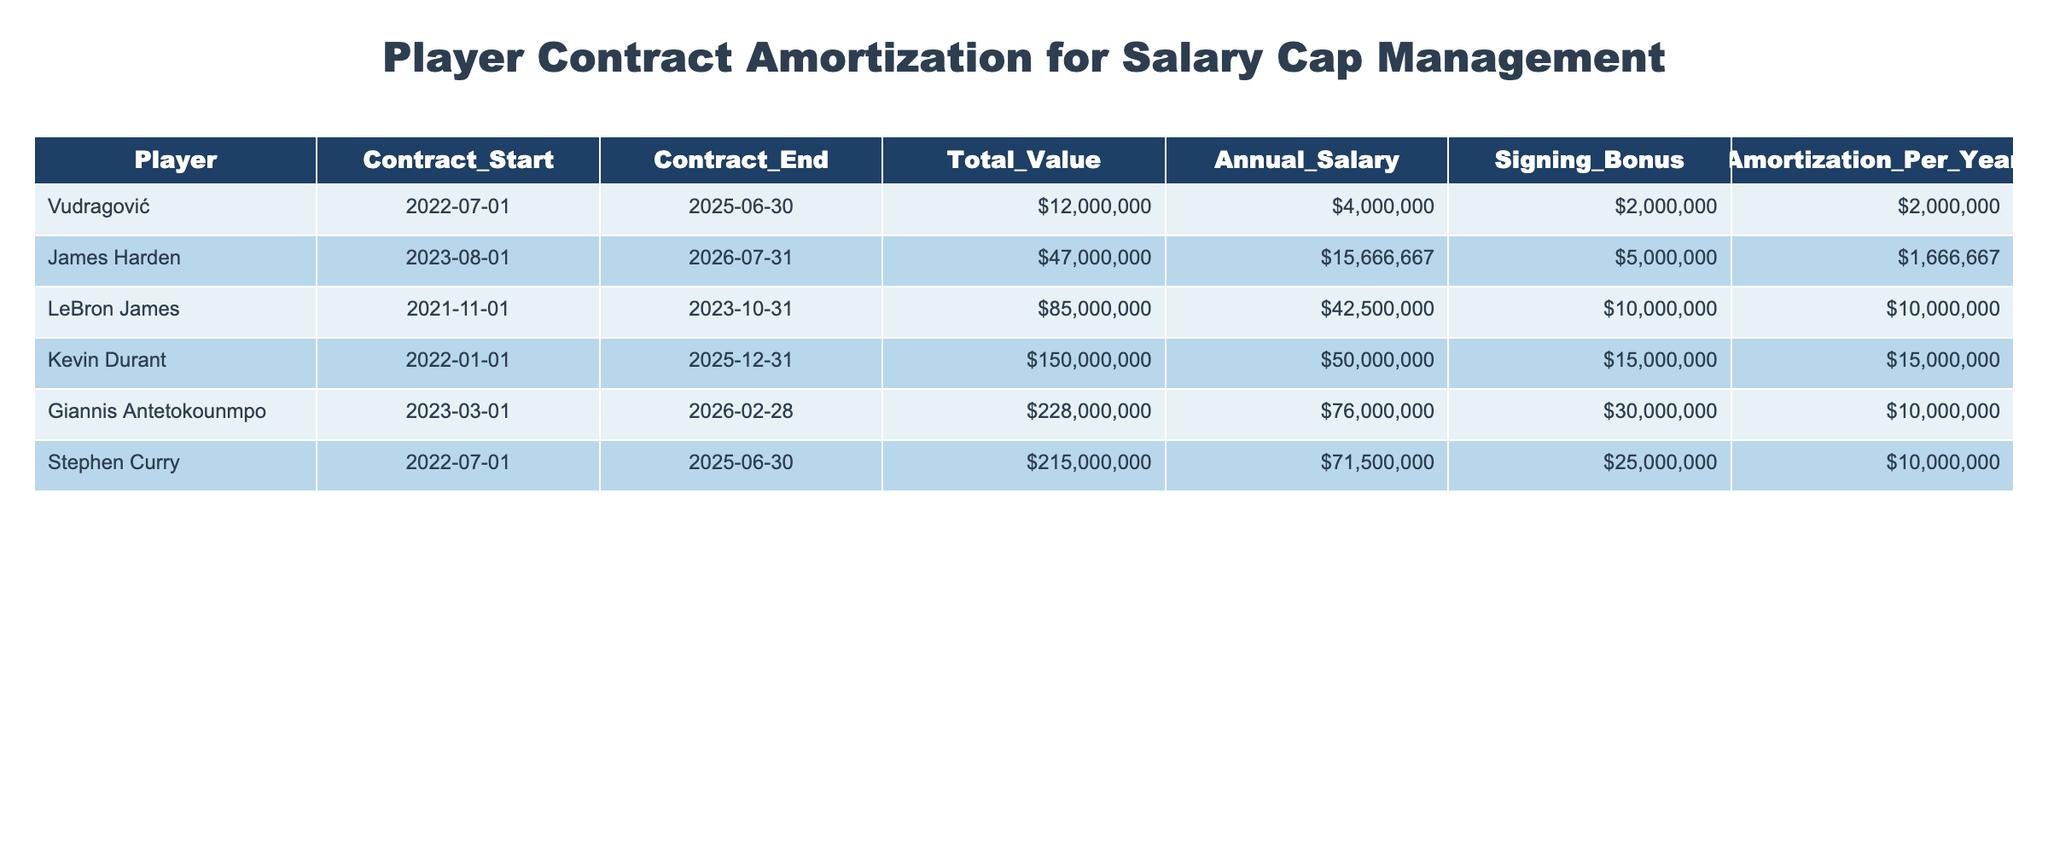What is the total contract value for Vudragović? The total contract value for Vudragović is listed directly in the table under the "Total_Value" column. Referring to that row, the value is $12,000,000.
Answer: $12,000,000 Who has the highest annual salary in the table? To determine who has the highest annual salary, I need to compare the values in the "Annual_Salary" column. LeBron James has the highest annual salary of $42,500,000.
Answer: LeBron James What is the signing bonus for Kevin Durant? The signing bonus for Kevin Durant can be found in the "Signing_Bonus" column in his respective row. The value is $15,000,000.
Answer: $15,000,000 Is Giannis Antetokounmpo's signing bonus greater than Vudragović's? I will compare the signing bonuses in the respective rows: Giannis Antetokounmpo has a signing bonus of $30,000,000 while Vudragović has $2,000,000. Since $30,000,000 is greater than $2,000,000, the answer is yes.
Answer: Yes What is the total amortization per year for all players combined? To find the total amortization per year, I will sum the "Amortization_Per_Year" values for each player. This calculates to $2,000,000 + $1,666,667 + $10,000,000 + $15,000,000 + $10,000,000 + $10,000,000 = $48,666,667.
Answer: $48,666,667 What is the average annual salary of the players in the table? I will sum the values in the "Annual_Salary" column, which gives: $4,000,000 + $15,666,667 + $42,500,000 + $50,000,000 + $76,000,000 + $71,500,000 = $259,666,667. There are 6 players, so the average is $259,666,667 divided by 6, which equals $43,277,778.
Answer: $43,277,778 Does Stephen Curry have the longest contract duration? To determine this, I can calculate the duration of each player's contract by comparing the "Contract_Start" and "Contract_End" dates. Stephen Curry's contract runs from July 1, 2022, to June 30, 2025, for 3 years. The longest duration belongs to Giannis Antetokounmpo, whose contract lasts from March 1, 2023, to February 28, 2026, also 3 years, creating a tie. Therefore, the answer is no, he does not have the longest contract.
Answer: No Who has a signing bonus less than $1,000,000? I will check the "Signing_Bonus" column for any value less than $1,000,000. None of the players have a signing bonus below this amount since all values are higher.
Answer: No 